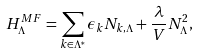<formula> <loc_0><loc_0><loc_500><loc_500>H _ { \Lambda } ^ { M F } = \sum _ { k \in \Lambda ^ { * } } \epsilon _ { k } N _ { k , \Lambda } + \frac { \lambda } { V } N _ { \Lambda } ^ { 2 } ,</formula> 